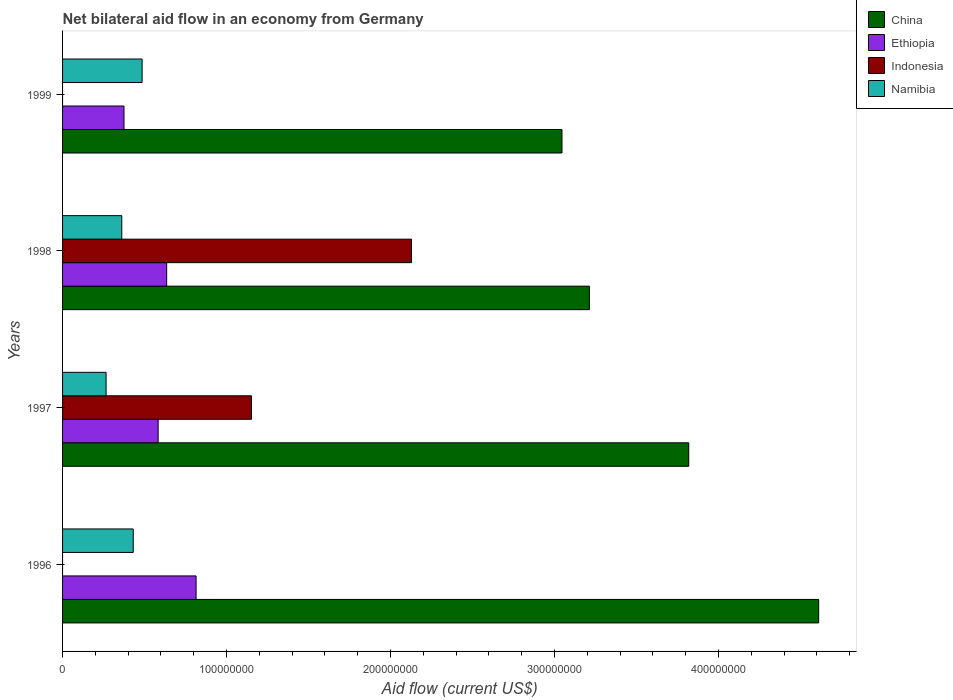How many different coloured bars are there?
Offer a very short reply. 4. Are the number of bars on each tick of the Y-axis equal?
Your response must be concise. No. How many bars are there on the 2nd tick from the top?
Provide a succinct answer. 4. How many bars are there on the 4th tick from the bottom?
Make the answer very short. 3. In how many cases, is the number of bars for a given year not equal to the number of legend labels?
Provide a succinct answer. 2. What is the net bilateral aid flow in China in 1999?
Give a very brief answer. 3.05e+08. Across all years, what is the maximum net bilateral aid flow in China?
Offer a terse response. 4.61e+08. Across all years, what is the minimum net bilateral aid flow in Ethiopia?
Offer a very short reply. 3.75e+07. What is the total net bilateral aid flow in China in the graph?
Ensure brevity in your answer.  1.47e+09. What is the difference between the net bilateral aid flow in Ethiopia in 1996 and that in 1997?
Keep it short and to the point. 2.31e+07. What is the difference between the net bilateral aid flow in Indonesia in 1996 and the net bilateral aid flow in Ethiopia in 1999?
Keep it short and to the point. -3.75e+07. What is the average net bilateral aid flow in China per year?
Your response must be concise. 3.67e+08. In the year 1998, what is the difference between the net bilateral aid flow in China and net bilateral aid flow in Indonesia?
Provide a short and direct response. 1.09e+08. What is the ratio of the net bilateral aid flow in Ethiopia in 1998 to that in 1999?
Offer a terse response. 1.69. What is the difference between the highest and the second highest net bilateral aid flow in Ethiopia?
Your answer should be very brief. 1.79e+07. What is the difference between the highest and the lowest net bilateral aid flow in China?
Your answer should be very brief. 1.57e+08. In how many years, is the net bilateral aid flow in Indonesia greater than the average net bilateral aid flow in Indonesia taken over all years?
Provide a short and direct response. 2. Is the sum of the net bilateral aid flow in China in 1997 and 1998 greater than the maximum net bilateral aid flow in Namibia across all years?
Your response must be concise. Yes. Are all the bars in the graph horizontal?
Provide a succinct answer. Yes. How many legend labels are there?
Offer a terse response. 4. How are the legend labels stacked?
Your response must be concise. Vertical. What is the title of the graph?
Ensure brevity in your answer.  Net bilateral aid flow in an economy from Germany. Does "Myanmar" appear as one of the legend labels in the graph?
Provide a succinct answer. No. What is the label or title of the X-axis?
Ensure brevity in your answer.  Aid flow (current US$). What is the label or title of the Y-axis?
Provide a succinct answer. Years. What is the Aid flow (current US$) in China in 1996?
Your answer should be compact. 4.61e+08. What is the Aid flow (current US$) of Ethiopia in 1996?
Your answer should be very brief. 8.14e+07. What is the Aid flow (current US$) of Namibia in 1996?
Provide a succinct answer. 4.31e+07. What is the Aid flow (current US$) in China in 1997?
Your response must be concise. 3.82e+08. What is the Aid flow (current US$) of Ethiopia in 1997?
Keep it short and to the point. 5.83e+07. What is the Aid flow (current US$) of Indonesia in 1997?
Ensure brevity in your answer.  1.15e+08. What is the Aid flow (current US$) of Namibia in 1997?
Offer a very short reply. 2.66e+07. What is the Aid flow (current US$) of China in 1998?
Ensure brevity in your answer.  3.21e+08. What is the Aid flow (current US$) of Ethiopia in 1998?
Provide a succinct answer. 6.35e+07. What is the Aid flow (current US$) of Indonesia in 1998?
Give a very brief answer. 2.13e+08. What is the Aid flow (current US$) in Namibia in 1998?
Offer a very short reply. 3.61e+07. What is the Aid flow (current US$) of China in 1999?
Keep it short and to the point. 3.05e+08. What is the Aid flow (current US$) of Ethiopia in 1999?
Provide a succinct answer. 3.75e+07. What is the Aid flow (current US$) in Indonesia in 1999?
Your answer should be very brief. 0. What is the Aid flow (current US$) of Namibia in 1999?
Ensure brevity in your answer.  4.85e+07. Across all years, what is the maximum Aid flow (current US$) in China?
Provide a short and direct response. 4.61e+08. Across all years, what is the maximum Aid flow (current US$) in Ethiopia?
Provide a short and direct response. 8.14e+07. Across all years, what is the maximum Aid flow (current US$) in Indonesia?
Ensure brevity in your answer.  2.13e+08. Across all years, what is the maximum Aid flow (current US$) in Namibia?
Provide a short and direct response. 4.85e+07. Across all years, what is the minimum Aid flow (current US$) of China?
Offer a terse response. 3.05e+08. Across all years, what is the minimum Aid flow (current US$) in Ethiopia?
Offer a very short reply. 3.75e+07. Across all years, what is the minimum Aid flow (current US$) of Indonesia?
Offer a very short reply. 0. Across all years, what is the minimum Aid flow (current US$) in Namibia?
Ensure brevity in your answer.  2.66e+07. What is the total Aid flow (current US$) in China in the graph?
Your answer should be compact. 1.47e+09. What is the total Aid flow (current US$) of Ethiopia in the graph?
Give a very brief answer. 2.41e+08. What is the total Aid flow (current US$) of Indonesia in the graph?
Offer a very short reply. 3.28e+08. What is the total Aid flow (current US$) in Namibia in the graph?
Your answer should be very brief. 1.54e+08. What is the difference between the Aid flow (current US$) of China in 1996 and that in 1997?
Provide a succinct answer. 7.92e+07. What is the difference between the Aid flow (current US$) of Ethiopia in 1996 and that in 1997?
Your answer should be compact. 2.31e+07. What is the difference between the Aid flow (current US$) of Namibia in 1996 and that in 1997?
Keep it short and to the point. 1.66e+07. What is the difference between the Aid flow (current US$) of China in 1996 and that in 1998?
Keep it short and to the point. 1.40e+08. What is the difference between the Aid flow (current US$) in Ethiopia in 1996 and that in 1998?
Offer a very short reply. 1.79e+07. What is the difference between the Aid flow (current US$) of Namibia in 1996 and that in 1998?
Give a very brief answer. 6.99e+06. What is the difference between the Aid flow (current US$) in China in 1996 and that in 1999?
Provide a short and direct response. 1.57e+08. What is the difference between the Aid flow (current US$) in Ethiopia in 1996 and that in 1999?
Make the answer very short. 4.40e+07. What is the difference between the Aid flow (current US$) of Namibia in 1996 and that in 1999?
Provide a succinct answer. -5.41e+06. What is the difference between the Aid flow (current US$) in China in 1997 and that in 1998?
Give a very brief answer. 6.06e+07. What is the difference between the Aid flow (current US$) of Ethiopia in 1997 and that in 1998?
Make the answer very short. -5.19e+06. What is the difference between the Aid flow (current US$) in Indonesia in 1997 and that in 1998?
Offer a very short reply. -9.76e+07. What is the difference between the Aid flow (current US$) in Namibia in 1997 and that in 1998?
Ensure brevity in your answer.  -9.56e+06. What is the difference between the Aid flow (current US$) in China in 1997 and that in 1999?
Your answer should be very brief. 7.73e+07. What is the difference between the Aid flow (current US$) in Ethiopia in 1997 and that in 1999?
Provide a short and direct response. 2.08e+07. What is the difference between the Aid flow (current US$) in Namibia in 1997 and that in 1999?
Keep it short and to the point. -2.20e+07. What is the difference between the Aid flow (current US$) in China in 1998 and that in 1999?
Keep it short and to the point. 1.67e+07. What is the difference between the Aid flow (current US$) in Ethiopia in 1998 and that in 1999?
Offer a terse response. 2.60e+07. What is the difference between the Aid flow (current US$) of Namibia in 1998 and that in 1999?
Offer a very short reply. -1.24e+07. What is the difference between the Aid flow (current US$) of China in 1996 and the Aid flow (current US$) of Ethiopia in 1997?
Give a very brief answer. 4.03e+08. What is the difference between the Aid flow (current US$) of China in 1996 and the Aid flow (current US$) of Indonesia in 1997?
Give a very brief answer. 3.46e+08. What is the difference between the Aid flow (current US$) of China in 1996 and the Aid flow (current US$) of Namibia in 1997?
Give a very brief answer. 4.35e+08. What is the difference between the Aid flow (current US$) in Ethiopia in 1996 and the Aid flow (current US$) in Indonesia in 1997?
Provide a succinct answer. -3.38e+07. What is the difference between the Aid flow (current US$) in Ethiopia in 1996 and the Aid flow (current US$) in Namibia in 1997?
Your answer should be compact. 5.49e+07. What is the difference between the Aid flow (current US$) in China in 1996 and the Aid flow (current US$) in Ethiopia in 1998?
Offer a very short reply. 3.98e+08. What is the difference between the Aid flow (current US$) in China in 1996 and the Aid flow (current US$) in Indonesia in 1998?
Give a very brief answer. 2.48e+08. What is the difference between the Aid flow (current US$) in China in 1996 and the Aid flow (current US$) in Namibia in 1998?
Keep it short and to the point. 4.25e+08. What is the difference between the Aid flow (current US$) of Ethiopia in 1996 and the Aid flow (current US$) of Indonesia in 1998?
Give a very brief answer. -1.31e+08. What is the difference between the Aid flow (current US$) in Ethiopia in 1996 and the Aid flow (current US$) in Namibia in 1998?
Provide a succinct answer. 4.53e+07. What is the difference between the Aid flow (current US$) of China in 1996 and the Aid flow (current US$) of Ethiopia in 1999?
Provide a succinct answer. 4.24e+08. What is the difference between the Aid flow (current US$) in China in 1996 and the Aid flow (current US$) in Namibia in 1999?
Offer a very short reply. 4.13e+08. What is the difference between the Aid flow (current US$) in Ethiopia in 1996 and the Aid flow (current US$) in Namibia in 1999?
Keep it short and to the point. 3.29e+07. What is the difference between the Aid flow (current US$) of China in 1997 and the Aid flow (current US$) of Ethiopia in 1998?
Offer a terse response. 3.18e+08. What is the difference between the Aid flow (current US$) of China in 1997 and the Aid flow (current US$) of Indonesia in 1998?
Your response must be concise. 1.69e+08. What is the difference between the Aid flow (current US$) in China in 1997 and the Aid flow (current US$) in Namibia in 1998?
Your answer should be very brief. 3.46e+08. What is the difference between the Aid flow (current US$) of Ethiopia in 1997 and the Aid flow (current US$) of Indonesia in 1998?
Your answer should be very brief. -1.54e+08. What is the difference between the Aid flow (current US$) in Ethiopia in 1997 and the Aid flow (current US$) in Namibia in 1998?
Give a very brief answer. 2.22e+07. What is the difference between the Aid flow (current US$) of Indonesia in 1997 and the Aid flow (current US$) of Namibia in 1998?
Your response must be concise. 7.91e+07. What is the difference between the Aid flow (current US$) in China in 1997 and the Aid flow (current US$) in Ethiopia in 1999?
Provide a succinct answer. 3.44e+08. What is the difference between the Aid flow (current US$) of China in 1997 and the Aid flow (current US$) of Namibia in 1999?
Keep it short and to the point. 3.33e+08. What is the difference between the Aid flow (current US$) in Ethiopia in 1997 and the Aid flow (current US$) in Namibia in 1999?
Provide a short and direct response. 9.79e+06. What is the difference between the Aid flow (current US$) in Indonesia in 1997 and the Aid flow (current US$) in Namibia in 1999?
Provide a short and direct response. 6.67e+07. What is the difference between the Aid flow (current US$) of China in 1998 and the Aid flow (current US$) of Ethiopia in 1999?
Give a very brief answer. 2.84e+08. What is the difference between the Aid flow (current US$) of China in 1998 and the Aid flow (current US$) of Namibia in 1999?
Your answer should be compact. 2.73e+08. What is the difference between the Aid flow (current US$) in Ethiopia in 1998 and the Aid flow (current US$) in Namibia in 1999?
Ensure brevity in your answer.  1.50e+07. What is the difference between the Aid flow (current US$) of Indonesia in 1998 and the Aid flow (current US$) of Namibia in 1999?
Make the answer very short. 1.64e+08. What is the average Aid flow (current US$) in China per year?
Your answer should be very brief. 3.67e+08. What is the average Aid flow (current US$) of Ethiopia per year?
Make the answer very short. 6.02e+07. What is the average Aid flow (current US$) of Indonesia per year?
Provide a short and direct response. 8.20e+07. What is the average Aid flow (current US$) of Namibia per year?
Your answer should be very brief. 3.86e+07. In the year 1996, what is the difference between the Aid flow (current US$) in China and Aid flow (current US$) in Ethiopia?
Keep it short and to the point. 3.80e+08. In the year 1996, what is the difference between the Aid flow (current US$) of China and Aid flow (current US$) of Namibia?
Your response must be concise. 4.18e+08. In the year 1996, what is the difference between the Aid flow (current US$) in Ethiopia and Aid flow (current US$) in Namibia?
Your answer should be compact. 3.83e+07. In the year 1997, what is the difference between the Aid flow (current US$) of China and Aid flow (current US$) of Ethiopia?
Offer a very short reply. 3.24e+08. In the year 1997, what is the difference between the Aid flow (current US$) in China and Aid flow (current US$) in Indonesia?
Offer a very short reply. 2.67e+08. In the year 1997, what is the difference between the Aid flow (current US$) in China and Aid flow (current US$) in Namibia?
Give a very brief answer. 3.55e+08. In the year 1997, what is the difference between the Aid flow (current US$) of Ethiopia and Aid flow (current US$) of Indonesia?
Offer a terse response. -5.69e+07. In the year 1997, what is the difference between the Aid flow (current US$) in Ethiopia and Aid flow (current US$) in Namibia?
Provide a short and direct response. 3.18e+07. In the year 1997, what is the difference between the Aid flow (current US$) of Indonesia and Aid flow (current US$) of Namibia?
Your response must be concise. 8.87e+07. In the year 1998, what is the difference between the Aid flow (current US$) of China and Aid flow (current US$) of Ethiopia?
Make the answer very short. 2.58e+08. In the year 1998, what is the difference between the Aid flow (current US$) in China and Aid flow (current US$) in Indonesia?
Make the answer very short. 1.09e+08. In the year 1998, what is the difference between the Aid flow (current US$) of China and Aid flow (current US$) of Namibia?
Offer a terse response. 2.85e+08. In the year 1998, what is the difference between the Aid flow (current US$) of Ethiopia and Aid flow (current US$) of Indonesia?
Offer a very short reply. -1.49e+08. In the year 1998, what is the difference between the Aid flow (current US$) of Ethiopia and Aid flow (current US$) of Namibia?
Your response must be concise. 2.74e+07. In the year 1998, what is the difference between the Aid flow (current US$) of Indonesia and Aid flow (current US$) of Namibia?
Ensure brevity in your answer.  1.77e+08. In the year 1999, what is the difference between the Aid flow (current US$) of China and Aid flow (current US$) of Ethiopia?
Your answer should be very brief. 2.67e+08. In the year 1999, what is the difference between the Aid flow (current US$) of China and Aid flow (current US$) of Namibia?
Your answer should be compact. 2.56e+08. In the year 1999, what is the difference between the Aid flow (current US$) in Ethiopia and Aid flow (current US$) in Namibia?
Ensure brevity in your answer.  -1.10e+07. What is the ratio of the Aid flow (current US$) in China in 1996 to that in 1997?
Ensure brevity in your answer.  1.21. What is the ratio of the Aid flow (current US$) in Ethiopia in 1996 to that in 1997?
Give a very brief answer. 1.4. What is the ratio of the Aid flow (current US$) in Namibia in 1996 to that in 1997?
Keep it short and to the point. 1.62. What is the ratio of the Aid flow (current US$) of China in 1996 to that in 1998?
Offer a very short reply. 1.44. What is the ratio of the Aid flow (current US$) of Ethiopia in 1996 to that in 1998?
Make the answer very short. 1.28. What is the ratio of the Aid flow (current US$) of Namibia in 1996 to that in 1998?
Your answer should be compact. 1.19. What is the ratio of the Aid flow (current US$) of China in 1996 to that in 1999?
Make the answer very short. 1.51. What is the ratio of the Aid flow (current US$) in Ethiopia in 1996 to that in 1999?
Offer a terse response. 2.17. What is the ratio of the Aid flow (current US$) in Namibia in 1996 to that in 1999?
Your answer should be compact. 0.89. What is the ratio of the Aid flow (current US$) of China in 1997 to that in 1998?
Keep it short and to the point. 1.19. What is the ratio of the Aid flow (current US$) of Ethiopia in 1997 to that in 1998?
Your answer should be compact. 0.92. What is the ratio of the Aid flow (current US$) in Indonesia in 1997 to that in 1998?
Your answer should be compact. 0.54. What is the ratio of the Aid flow (current US$) in Namibia in 1997 to that in 1998?
Offer a terse response. 0.74. What is the ratio of the Aid flow (current US$) of China in 1997 to that in 1999?
Your response must be concise. 1.25. What is the ratio of the Aid flow (current US$) in Ethiopia in 1997 to that in 1999?
Make the answer very short. 1.56. What is the ratio of the Aid flow (current US$) in Namibia in 1997 to that in 1999?
Provide a succinct answer. 0.55. What is the ratio of the Aid flow (current US$) in China in 1998 to that in 1999?
Your answer should be very brief. 1.05. What is the ratio of the Aid flow (current US$) in Ethiopia in 1998 to that in 1999?
Give a very brief answer. 1.69. What is the ratio of the Aid flow (current US$) in Namibia in 1998 to that in 1999?
Ensure brevity in your answer.  0.74. What is the difference between the highest and the second highest Aid flow (current US$) of China?
Ensure brevity in your answer.  7.92e+07. What is the difference between the highest and the second highest Aid flow (current US$) in Ethiopia?
Your answer should be very brief. 1.79e+07. What is the difference between the highest and the second highest Aid flow (current US$) in Namibia?
Give a very brief answer. 5.41e+06. What is the difference between the highest and the lowest Aid flow (current US$) in China?
Provide a short and direct response. 1.57e+08. What is the difference between the highest and the lowest Aid flow (current US$) in Ethiopia?
Your answer should be very brief. 4.40e+07. What is the difference between the highest and the lowest Aid flow (current US$) in Indonesia?
Your answer should be very brief. 2.13e+08. What is the difference between the highest and the lowest Aid flow (current US$) in Namibia?
Keep it short and to the point. 2.20e+07. 